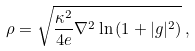Convert formula to latex. <formula><loc_0><loc_0><loc_500><loc_500>\rho = \sqrt { \frac { \kappa ^ { 2 } } { 4 e } \nabla ^ { 2 } \ln { ( 1 + | g | ^ { 2 } ) } } \, ,</formula> 